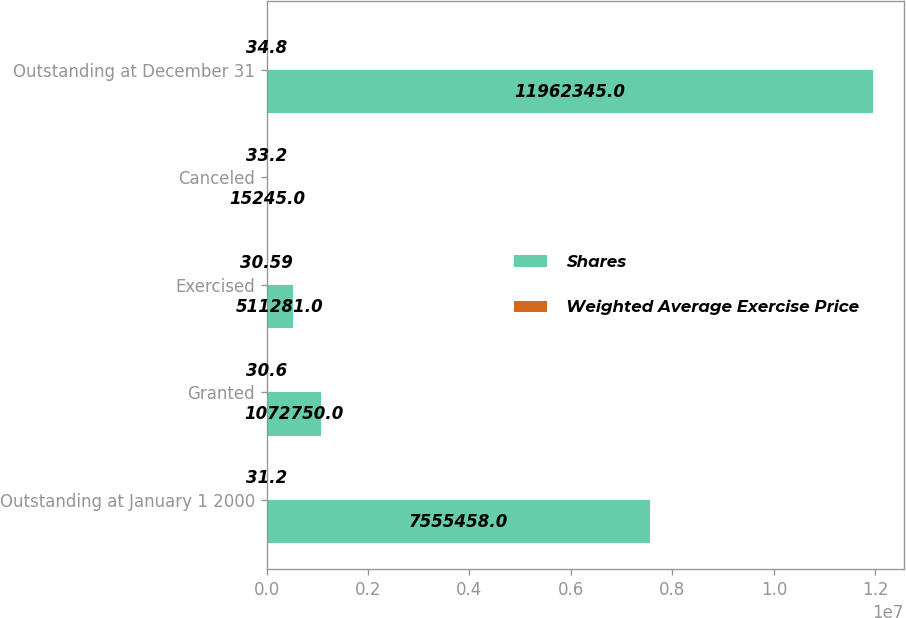Convert chart to OTSL. <chart><loc_0><loc_0><loc_500><loc_500><stacked_bar_chart><ecel><fcel>Outstanding at January 1 2000<fcel>Granted<fcel>Exercised<fcel>Canceled<fcel>Outstanding at December 31<nl><fcel>Shares<fcel>7.55546e+06<fcel>1.07275e+06<fcel>511281<fcel>15245<fcel>1.19623e+07<nl><fcel>Weighted Average Exercise Price<fcel>31.2<fcel>30.6<fcel>30.59<fcel>33.2<fcel>34.8<nl></chart> 